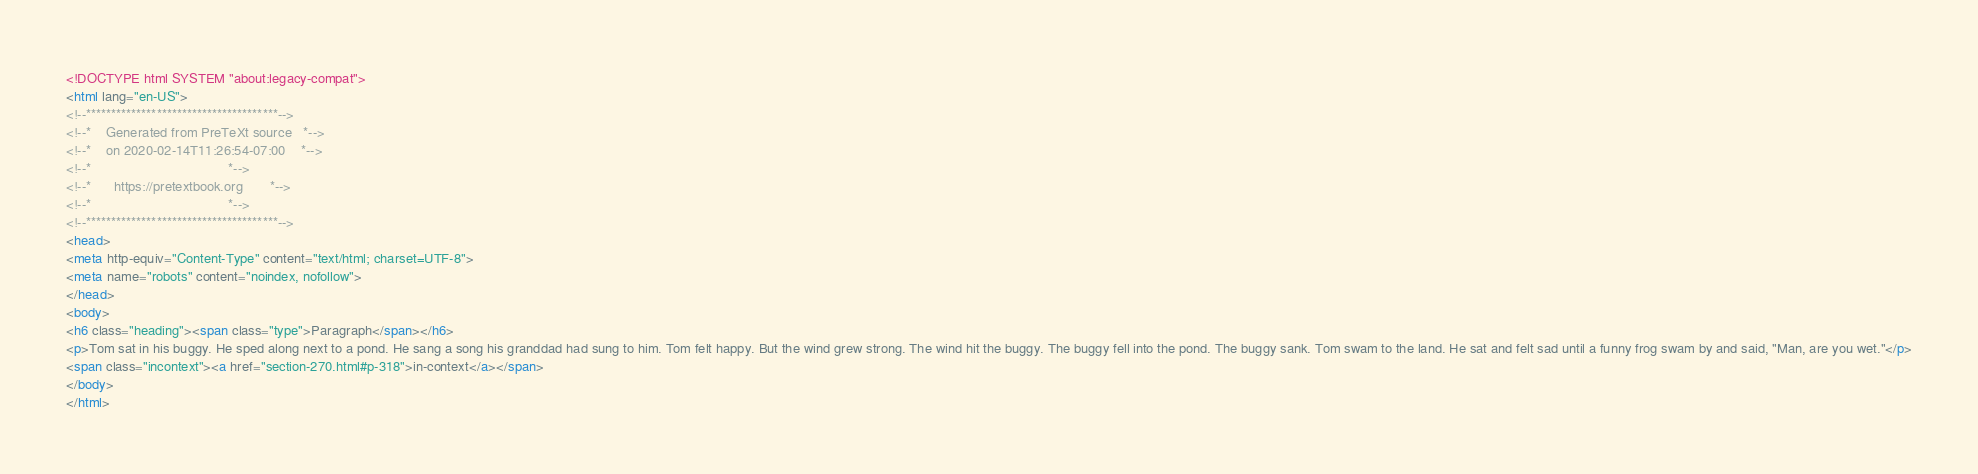<code> <loc_0><loc_0><loc_500><loc_500><_HTML_><!DOCTYPE html SYSTEM "about:legacy-compat">
<html lang="en-US">
<!--**************************************-->
<!--*    Generated from PreTeXt source   *-->
<!--*    on 2020-02-14T11:26:54-07:00    *-->
<!--*                                    *-->
<!--*      https://pretextbook.org       *-->
<!--*                                    *-->
<!--**************************************-->
<head>
<meta http-equiv="Content-Type" content="text/html; charset=UTF-8">
<meta name="robots" content="noindex, nofollow">
</head>
<body>
<h6 class="heading"><span class="type">Paragraph</span></h6>
<p>Tom sat in his buggy. He sped along next to a pond. He sang a song his granddad had sung to him. Tom felt happy. But the wind grew strong. The wind hit the buggy. The buggy fell into the pond. The buggy sank. Tom swam to the land. He sat and felt sad until a funny frog swam by and said, "Man, are you wet."</p>
<span class="incontext"><a href="section-270.html#p-318">in-context</a></span>
</body>
</html>
</code> 